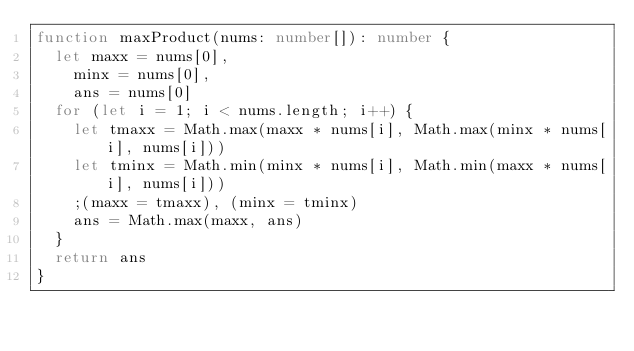Convert code to text. <code><loc_0><loc_0><loc_500><loc_500><_TypeScript_>function maxProduct(nums: number[]): number {
  let maxx = nums[0],
    minx = nums[0],
    ans = nums[0]
  for (let i = 1; i < nums.length; i++) {
    let tmaxx = Math.max(maxx * nums[i], Math.max(minx * nums[i], nums[i]))
    let tminx = Math.min(minx * nums[i], Math.min(maxx * nums[i], nums[i]))
    ;(maxx = tmaxx), (minx = tminx)
    ans = Math.max(maxx, ans)
  }
  return ans
}
</code> 